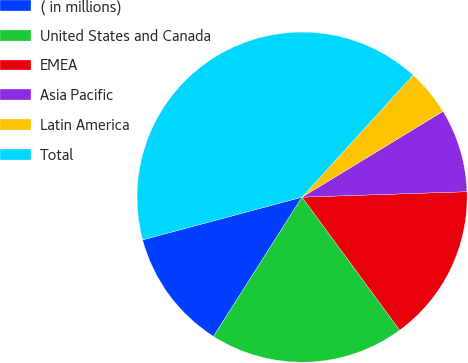Convert chart to OTSL. <chart><loc_0><loc_0><loc_500><loc_500><pie_chart><fcel>( in millions)<fcel>United States and Canada<fcel>EMEA<fcel>Asia Pacific<fcel>Latin America<fcel>Total<nl><fcel>11.82%<fcel>19.09%<fcel>15.45%<fcel>8.18%<fcel>4.54%<fcel>40.92%<nl></chart> 